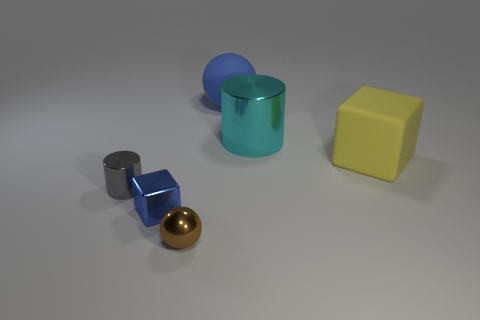Add 3 tiny red balls. How many objects exist? 9 Subtract all spheres. How many objects are left? 4 Add 4 big blue metal balls. How many big blue metal balls exist? 4 Subtract 1 brown balls. How many objects are left? 5 Subtract all tiny brown objects. Subtract all small brown shiny spheres. How many objects are left? 4 Add 3 small blue objects. How many small blue objects are left? 4 